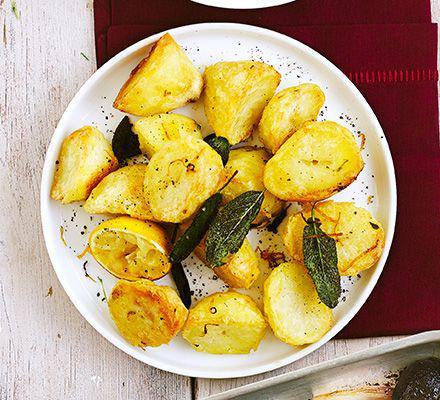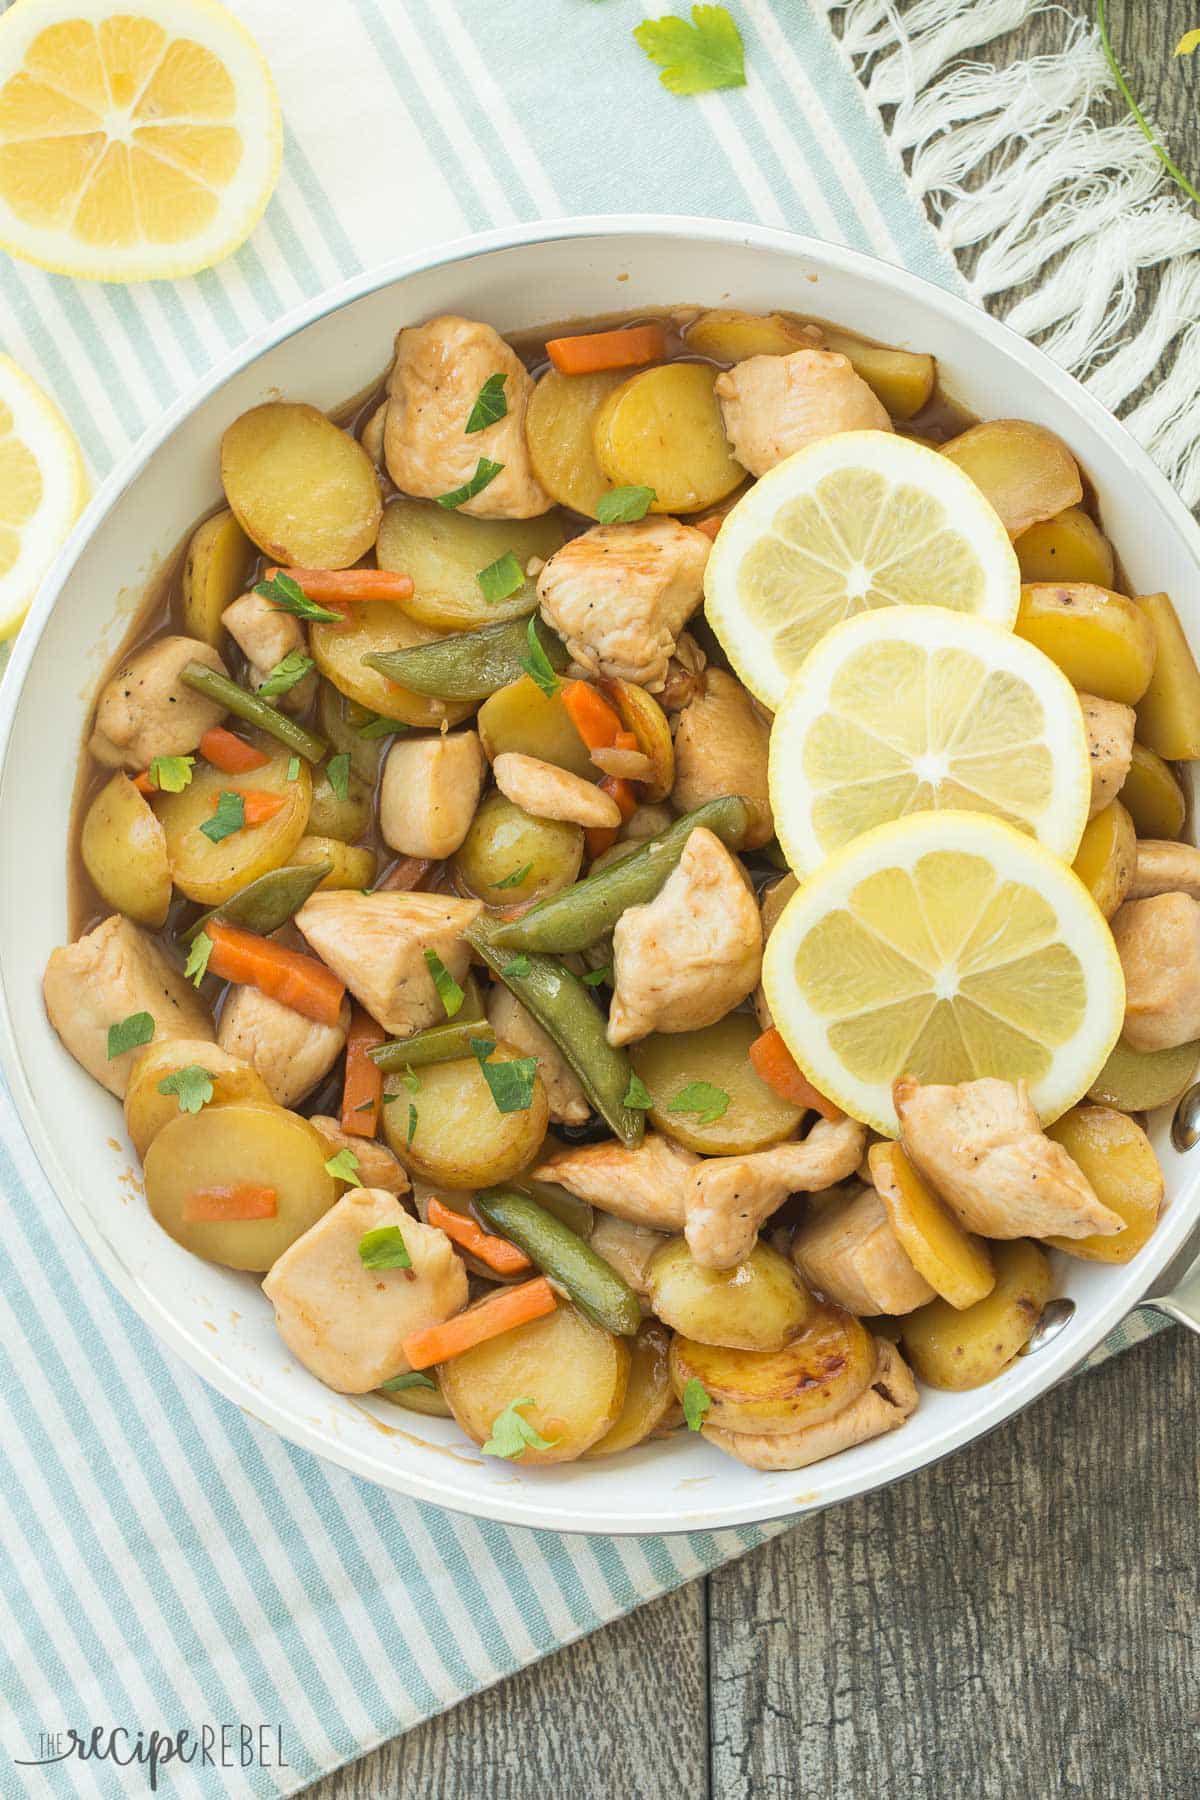The first image is the image on the left, the second image is the image on the right. Analyze the images presented: Is the assertion "The left image shows a round bowl without handles containing potato sections, and the right image shows a white interiored dish with handles containing sliced potato pieces." valid? Answer yes or no. No. 